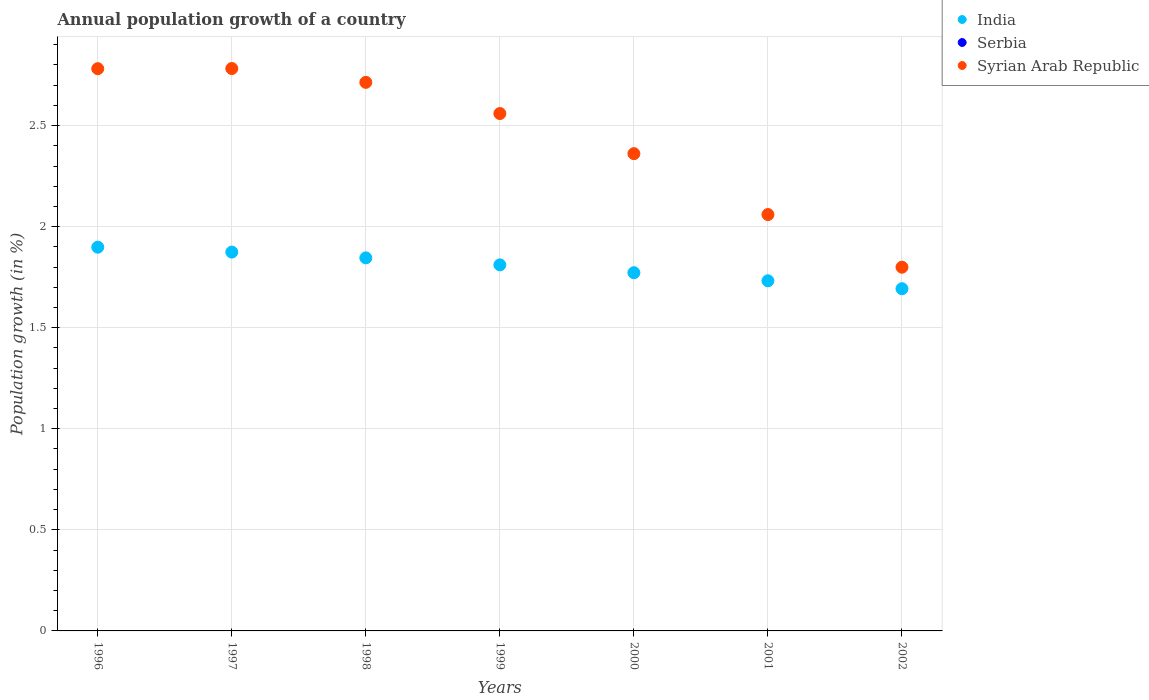What is the annual population growth in Syrian Arab Republic in 1998?
Your answer should be very brief. 2.71. Across all years, what is the maximum annual population growth in Syrian Arab Republic?
Provide a short and direct response. 2.78. Across all years, what is the minimum annual population growth in Serbia?
Provide a short and direct response. 0. What is the total annual population growth in Syrian Arab Republic in the graph?
Your answer should be compact. 17.06. What is the difference between the annual population growth in Syrian Arab Republic in 1996 and that in 1999?
Your response must be concise. 0.22. What is the difference between the annual population growth in Syrian Arab Republic in 2002 and the annual population growth in Serbia in 1996?
Your answer should be very brief. 1.8. What is the average annual population growth in India per year?
Your response must be concise. 1.8. In the year 2002, what is the difference between the annual population growth in Syrian Arab Republic and annual population growth in India?
Your answer should be very brief. 0.11. In how many years, is the annual population growth in Serbia greater than 0.2 %?
Your answer should be very brief. 0. What is the ratio of the annual population growth in Syrian Arab Republic in 2000 to that in 2002?
Make the answer very short. 1.31. What is the difference between the highest and the second highest annual population growth in Syrian Arab Republic?
Make the answer very short. 0. What is the difference between the highest and the lowest annual population growth in India?
Your answer should be compact. 0.21. In how many years, is the annual population growth in Serbia greater than the average annual population growth in Serbia taken over all years?
Your answer should be very brief. 0. Does the annual population growth in India monotonically increase over the years?
Your response must be concise. No. Is the annual population growth in India strictly less than the annual population growth in Syrian Arab Republic over the years?
Make the answer very short. Yes. How many dotlines are there?
Provide a succinct answer. 2. How many years are there in the graph?
Provide a succinct answer. 7. What is the difference between two consecutive major ticks on the Y-axis?
Your response must be concise. 0.5. Does the graph contain any zero values?
Offer a terse response. Yes. Does the graph contain grids?
Your answer should be very brief. Yes. How many legend labels are there?
Your answer should be compact. 3. How are the legend labels stacked?
Provide a succinct answer. Vertical. What is the title of the graph?
Offer a terse response. Annual population growth of a country. What is the label or title of the Y-axis?
Give a very brief answer. Population growth (in %). What is the Population growth (in %) in India in 1996?
Keep it short and to the point. 1.9. What is the Population growth (in %) of Serbia in 1996?
Provide a succinct answer. 0. What is the Population growth (in %) in Syrian Arab Republic in 1996?
Ensure brevity in your answer.  2.78. What is the Population growth (in %) in India in 1997?
Ensure brevity in your answer.  1.87. What is the Population growth (in %) in Serbia in 1997?
Keep it short and to the point. 0. What is the Population growth (in %) of Syrian Arab Republic in 1997?
Offer a very short reply. 2.78. What is the Population growth (in %) in India in 1998?
Your response must be concise. 1.85. What is the Population growth (in %) of Syrian Arab Republic in 1998?
Give a very brief answer. 2.71. What is the Population growth (in %) of India in 1999?
Your answer should be compact. 1.81. What is the Population growth (in %) in Syrian Arab Republic in 1999?
Keep it short and to the point. 2.56. What is the Population growth (in %) in India in 2000?
Your answer should be compact. 1.77. What is the Population growth (in %) of Syrian Arab Republic in 2000?
Make the answer very short. 2.36. What is the Population growth (in %) in India in 2001?
Make the answer very short. 1.73. What is the Population growth (in %) of Syrian Arab Republic in 2001?
Offer a terse response. 2.06. What is the Population growth (in %) of India in 2002?
Give a very brief answer. 1.69. What is the Population growth (in %) of Serbia in 2002?
Provide a succinct answer. 0. What is the Population growth (in %) in Syrian Arab Republic in 2002?
Ensure brevity in your answer.  1.8. Across all years, what is the maximum Population growth (in %) in India?
Make the answer very short. 1.9. Across all years, what is the maximum Population growth (in %) of Syrian Arab Republic?
Keep it short and to the point. 2.78. Across all years, what is the minimum Population growth (in %) in India?
Offer a terse response. 1.69. Across all years, what is the minimum Population growth (in %) of Syrian Arab Republic?
Ensure brevity in your answer.  1.8. What is the total Population growth (in %) of India in the graph?
Provide a succinct answer. 12.63. What is the total Population growth (in %) in Serbia in the graph?
Your response must be concise. 0. What is the total Population growth (in %) in Syrian Arab Republic in the graph?
Provide a short and direct response. 17.06. What is the difference between the Population growth (in %) in India in 1996 and that in 1997?
Make the answer very short. 0.02. What is the difference between the Population growth (in %) of Syrian Arab Republic in 1996 and that in 1997?
Your answer should be compact. -0. What is the difference between the Population growth (in %) of India in 1996 and that in 1998?
Offer a terse response. 0.05. What is the difference between the Population growth (in %) in Syrian Arab Republic in 1996 and that in 1998?
Make the answer very short. 0.07. What is the difference between the Population growth (in %) in India in 1996 and that in 1999?
Give a very brief answer. 0.09. What is the difference between the Population growth (in %) in Syrian Arab Republic in 1996 and that in 1999?
Give a very brief answer. 0.22. What is the difference between the Population growth (in %) of India in 1996 and that in 2000?
Your answer should be very brief. 0.13. What is the difference between the Population growth (in %) of Syrian Arab Republic in 1996 and that in 2000?
Offer a very short reply. 0.42. What is the difference between the Population growth (in %) in India in 1996 and that in 2001?
Ensure brevity in your answer.  0.17. What is the difference between the Population growth (in %) of Syrian Arab Republic in 1996 and that in 2001?
Offer a terse response. 0.72. What is the difference between the Population growth (in %) in India in 1996 and that in 2002?
Your answer should be compact. 0.21. What is the difference between the Population growth (in %) of Syrian Arab Republic in 1996 and that in 2002?
Provide a succinct answer. 0.98. What is the difference between the Population growth (in %) of India in 1997 and that in 1998?
Provide a short and direct response. 0.03. What is the difference between the Population growth (in %) in Syrian Arab Republic in 1997 and that in 1998?
Your answer should be very brief. 0.07. What is the difference between the Population growth (in %) in India in 1997 and that in 1999?
Provide a short and direct response. 0.06. What is the difference between the Population growth (in %) of Syrian Arab Republic in 1997 and that in 1999?
Offer a terse response. 0.22. What is the difference between the Population growth (in %) of India in 1997 and that in 2000?
Keep it short and to the point. 0.1. What is the difference between the Population growth (in %) of Syrian Arab Republic in 1997 and that in 2000?
Keep it short and to the point. 0.42. What is the difference between the Population growth (in %) of India in 1997 and that in 2001?
Give a very brief answer. 0.14. What is the difference between the Population growth (in %) in Syrian Arab Republic in 1997 and that in 2001?
Offer a terse response. 0.72. What is the difference between the Population growth (in %) in India in 1997 and that in 2002?
Your response must be concise. 0.18. What is the difference between the Population growth (in %) in Syrian Arab Republic in 1997 and that in 2002?
Your answer should be very brief. 0.98. What is the difference between the Population growth (in %) of India in 1998 and that in 1999?
Keep it short and to the point. 0.03. What is the difference between the Population growth (in %) in Syrian Arab Republic in 1998 and that in 1999?
Give a very brief answer. 0.15. What is the difference between the Population growth (in %) of India in 1998 and that in 2000?
Give a very brief answer. 0.07. What is the difference between the Population growth (in %) of Syrian Arab Republic in 1998 and that in 2000?
Your response must be concise. 0.35. What is the difference between the Population growth (in %) of India in 1998 and that in 2001?
Ensure brevity in your answer.  0.11. What is the difference between the Population growth (in %) of Syrian Arab Republic in 1998 and that in 2001?
Ensure brevity in your answer.  0.65. What is the difference between the Population growth (in %) in India in 1998 and that in 2002?
Your answer should be compact. 0.15. What is the difference between the Population growth (in %) in Syrian Arab Republic in 1998 and that in 2002?
Your answer should be very brief. 0.91. What is the difference between the Population growth (in %) of India in 1999 and that in 2000?
Your response must be concise. 0.04. What is the difference between the Population growth (in %) of Syrian Arab Republic in 1999 and that in 2000?
Offer a very short reply. 0.2. What is the difference between the Population growth (in %) of India in 1999 and that in 2001?
Provide a short and direct response. 0.08. What is the difference between the Population growth (in %) in Syrian Arab Republic in 1999 and that in 2001?
Keep it short and to the point. 0.5. What is the difference between the Population growth (in %) of India in 1999 and that in 2002?
Your answer should be very brief. 0.12. What is the difference between the Population growth (in %) in Syrian Arab Republic in 1999 and that in 2002?
Keep it short and to the point. 0.76. What is the difference between the Population growth (in %) of India in 2000 and that in 2001?
Provide a short and direct response. 0.04. What is the difference between the Population growth (in %) of Syrian Arab Republic in 2000 and that in 2001?
Offer a very short reply. 0.3. What is the difference between the Population growth (in %) in India in 2000 and that in 2002?
Provide a short and direct response. 0.08. What is the difference between the Population growth (in %) in Syrian Arab Republic in 2000 and that in 2002?
Ensure brevity in your answer.  0.56. What is the difference between the Population growth (in %) in India in 2001 and that in 2002?
Make the answer very short. 0.04. What is the difference between the Population growth (in %) of Syrian Arab Republic in 2001 and that in 2002?
Make the answer very short. 0.26. What is the difference between the Population growth (in %) of India in 1996 and the Population growth (in %) of Syrian Arab Republic in 1997?
Provide a succinct answer. -0.88. What is the difference between the Population growth (in %) in India in 1996 and the Population growth (in %) in Syrian Arab Republic in 1998?
Ensure brevity in your answer.  -0.82. What is the difference between the Population growth (in %) in India in 1996 and the Population growth (in %) in Syrian Arab Republic in 1999?
Ensure brevity in your answer.  -0.66. What is the difference between the Population growth (in %) in India in 1996 and the Population growth (in %) in Syrian Arab Republic in 2000?
Offer a terse response. -0.46. What is the difference between the Population growth (in %) of India in 1996 and the Population growth (in %) of Syrian Arab Republic in 2001?
Your response must be concise. -0.16. What is the difference between the Population growth (in %) of India in 1996 and the Population growth (in %) of Syrian Arab Republic in 2002?
Your answer should be compact. 0.1. What is the difference between the Population growth (in %) in India in 1997 and the Population growth (in %) in Syrian Arab Republic in 1998?
Keep it short and to the point. -0.84. What is the difference between the Population growth (in %) in India in 1997 and the Population growth (in %) in Syrian Arab Republic in 1999?
Provide a short and direct response. -0.69. What is the difference between the Population growth (in %) in India in 1997 and the Population growth (in %) in Syrian Arab Republic in 2000?
Offer a very short reply. -0.49. What is the difference between the Population growth (in %) in India in 1997 and the Population growth (in %) in Syrian Arab Republic in 2001?
Provide a short and direct response. -0.19. What is the difference between the Population growth (in %) in India in 1997 and the Population growth (in %) in Syrian Arab Republic in 2002?
Ensure brevity in your answer.  0.07. What is the difference between the Population growth (in %) of India in 1998 and the Population growth (in %) of Syrian Arab Republic in 1999?
Ensure brevity in your answer.  -0.71. What is the difference between the Population growth (in %) in India in 1998 and the Population growth (in %) in Syrian Arab Republic in 2000?
Your answer should be compact. -0.52. What is the difference between the Population growth (in %) of India in 1998 and the Population growth (in %) of Syrian Arab Republic in 2001?
Your answer should be very brief. -0.21. What is the difference between the Population growth (in %) of India in 1998 and the Population growth (in %) of Syrian Arab Republic in 2002?
Your answer should be compact. 0.05. What is the difference between the Population growth (in %) of India in 1999 and the Population growth (in %) of Syrian Arab Republic in 2000?
Offer a very short reply. -0.55. What is the difference between the Population growth (in %) in India in 1999 and the Population growth (in %) in Syrian Arab Republic in 2001?
Your answer should be very brief. -0.25. What is the difference between the Population growth (in %) in India in 1999 and the Population growth (in %) in Syrian Arab Republic in 2002?
Ensure brevity in your answer.  0.01. What is the difference between the Population growth (in %) in India in 2000 and the Population growth (in %) in Syrian Arab Republic in 2001?
Offer a very short reply. -0.29. What is the difference between the Population growth (in %) in India in 2000 and the Population growth (in %) in Syrian Arab Republic in 2002?
Ensure brevity in your answer.  -0.03. What is the difference between the Population growth (in %) in India in 2001 and the Population growth (in %) in Syrian Arab Republic in 2002?
Your response must be concise. -0.07. What is the average Population growth (in %) in India per year?
Your response must be concise. 1.8. What is the average Population growth (in %) in Syrian Arab Republic per year?
Offer a very short reply. 2.44. In the year 1996, what is the difference between the Population growth (in %) in India and Population growth (in %) in Syrian Arab Republic?
Your response must be concise. -0.88. In the year 1997, what is the difference between the Population growth (in %) of India and Population growth (in %) of Syrian Arab Republic?
Offer a terse response. -0.91. In the year 1998, what is the difference between the Population growth (in %) in India and Population growth (in %) in Syrian Arab Republic?
Provide a short and direct response. -0.87. In the year 1999, what is the difference between the Population growth (in %) in India and Population growth (in %) in Syrian Arab Republic?
Offer a very short reply. -0.75. In the year 2000, what is the difference between the Population growth (in %) of India and Population growth (in %) of Syrian Arab Republic?
Offer a terse response. -0.59. In the year 2001, what is the difference between the Population growth (in %) of India and Population growth (in %) of Syrian Arab Republic?
Make the answer very short. -0.33. In the year 2002, what is the difference between the Population growth (in %) in India and Population growth (in %) in Syrian Arab Republic?
Your answer should be very brief. -0.11. What is the ratio of the Population growth (in %) in India in 1996 to that in 1997?
Your answer should be compact. 1.01. What is the ratio of the Population growth (in %) of India in 1996 to that in 1998?
Offer a very short reply. 1.03. What is the ratio of the Population growth (in %) of Syrian Arab Republic in 1996 to that in 1998?
Ensure brevity in your answer.  1.02. What is the ratio of the Population growth (in %) of India in 1996 to that in 1999?
Offer a very short reply. 1.05. What is the ratio of the Population growth (in %) of Syrian Arab Republic in 1996 to that in 1999?
Make the answer very short. 1.09. What is the ratio of the Population growth (in %) of India in 1996 to that in 2000?
Provide a short and direct response. 1.07. What is the ratio of the Population growth (in %) of Syrian Arab Republic in 1996 to that in 2000?
Your answer should be compact. 1.18. What is the ratio of the Population growth (in %) of India in 1996 to that in 2001?
Ensure brevity in your answer.  1.1. What is the ratio of the Population growth (in %) in Syrian Arab Republic in 1996 to that in 2001?
Your answer should be compact. 1.35. What is the ratio of the Population growth (in %) in India in 1996 to that in 2002?
Provide a short and direct response. 1.12. What is the ratio of the Population growth (in %) in Syrian Arab Republic in 1996 to that in 2002?
Provide a succinct answer. 1.55. What is the ratio of the Population growth (in %) of India in 1997 to that in 1998?
Provide a succinct answer. 1.02. What is the ratio of the Population growth (in %) in Syrian Arab Republic in 1997 to that in 1998?
Your answer should be very brief. 1.03. What is the ratio of the Population growth (in %) in India in 1997 to that in 1999?
Your answer should be very brief. 1.03. What is the ratio of the Population growth (in %) of Syrian Arab Republic in 1997 to that in 1999?
Give a very brief answer. 1.09. What is the ratio of the Population growth (in %) in India in 1997 to that in 2000?
Keep it short and to the point. 1.06. What is the ratio of the Population growth (in %) in Syrian Arab Republic in 1997 to that in 2000?
Offer a very short reply. 1.18. What is the ratio of the Population growth (in %) in India in 1997 to that in 2001?
Ensure brevity in your answer.  1.08. What is the ratio of the Population growth (in %) of Syrian Arab Republic in 1997 to that in 2001?
Ensure brevity in your answer.  1.35. What is the ratio of the Population growth (in %) in India in 1997 to that in 2002?
Offer a very short reply. 1.11. What is the ratio of the Population growth (in %) in Syrian Arab Republic in 1997 to that in 2002?
Your response must be concise. 1.55. What is the ratio of the Population growth (in %) of India in 1998 to that in 1999?
Your answer should be very brief. 1.02. What is the ratio of the Population growth (in %) in Syrian Arab Republic in 1998 to that in 1999?
Ensure brevity in your answer.  1.06. What is the ratio of the Population growth (in %) in India in 1998 to that in 2000?
Make the answer very short. 1.04. What is the ratio of the Population growth (in %) in Syrian Arab Republic in 1998 to that in 2000?
Ensure brevity in your answer.  1.15. What is the ratio of the Population growth (in %) of India in 1998 to that in 2001?
Provide a succinct answer. 1.07. What is the ratio of the Population growth (in %) of Syrian Arab Republic in 1998 to that in 2001?
Provide a short and direct response. 1.32. What is the ratio of the Population growth (in %) of India in 1998 to that in 2002?
Your answer should be very brief. 1.09. What is the ratio of the Population growth (in %) in Syrian Arab Republic in 1998 to that in 2002?
Your answer should be compact. 1.51. What is the ratio of the Population growth (in %) in India in 1999 to that in 2000?
Give a very brief answer. 1.02. What is the ratio of the Population growth (in %) of Syrian Arab Republic in 1999 to that in 2000?
Provide a short and direct response. 1.08. What is the ratio of the Population growth (in %) of India in 1999 to that in 2001?
Keep it short and to the point. 1.05. What is the ratio of the Population growth (in %) of Syrian Arab Republic in 1999 to that in 2001?
Give a very brief answer. 1.24. What is the ratio of the Population growth (in %) of India in 1999 to that in 2002?
Make the answer very short. 1.07. What is the ratio of the Population growth (in %) of Syrian Arab Republic in 1999 to that in 2002?
Offer a very short reply. 1.42. What is the ratio of the Population growth (in %) in India in 2000 to that in 2001?
Your answer should be compact. 1.02. What is the ratio of the Population growth (in %) in Syrian Arab Republic in 2000 to that in 2001?
Keep it short and to the point. 1.15. What is the ratio of the Population growth (in %) of India in 2000 to that in 2002?
Make the answer very short. 1.05. What is the ratio of the Population growth (in %) of Syrian Arab Republic in 2000 to that in 2002?
Ensure brevity in your answer.  1.31. What is the ratio of the Population growth (in %) of India in 2001 to that in 2002?
Offer a terse response. 1.02. What is the ratio of the Population growth (in %) of Syrian Arab Republic in 2001 to that in 2002?
Your answer should be compact. 1.14. What is the difference between the highest and the second highest Population growth (in %) of India?
Make the answer very short. 0.02. What is the difference between the highest and the second highest Population growth (in %) in Syrian Arab Republic?
Keep it short and to the point. 0. What is the difference between the highest and the lowest Population growth (in %) in India?
Your answer should be compact. 0.21. What is the difference between the highest and the lowest Population growth (in %) in Syrian Arab Republic?
Your answer should be very brief. 0.98. 